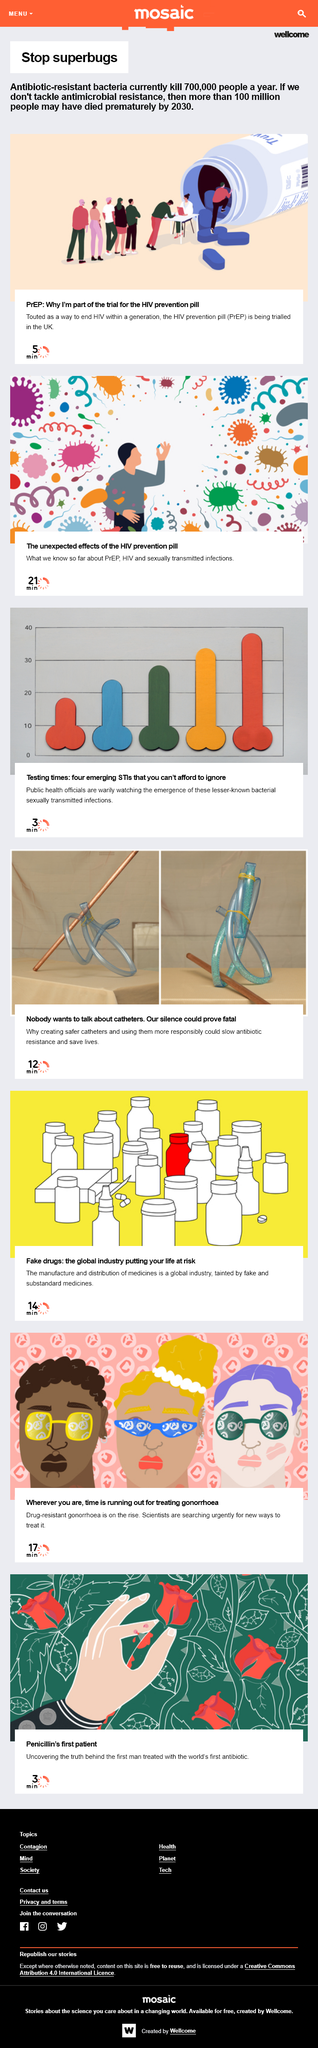List a handful of essential elements in this visual. There are currently four emerging sexually transmitted infections that public health officials are closely monitoring due to their potential to have significant public health impact. Unless we tackle antimicrobial resistance, more than 100 million people may die prematurely by 2030. Antibiotic resistant bacteria kill 700,000 people every year, making it a dire public health crisis that demands immediate attention and action. 